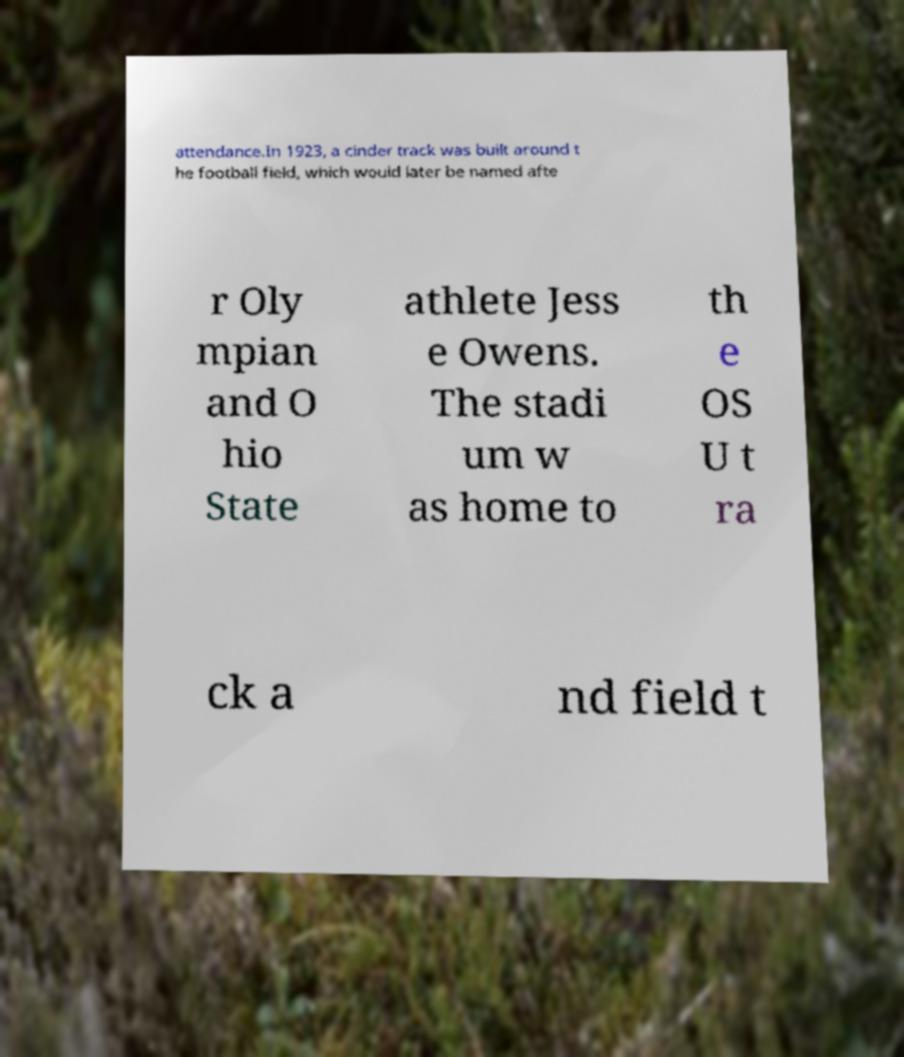Can you read and provide the text displayed in the image?This photo seems to have some interesting text. Can you extract and type it out for me? attendance.In 1923, a cinder track was built around t he football field, which would later be named afte r Oly mpian and O hio State athlete Jess e Owens. The stadi um w as home to th e OS U t ra ck a nd field t 